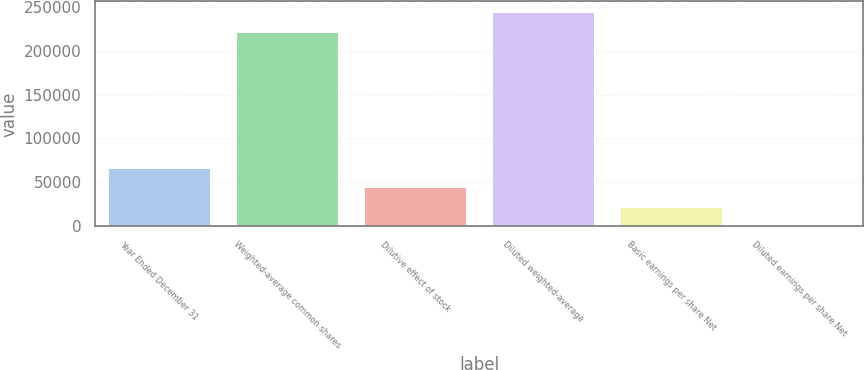Convert chart to OTSL. <chart><loc_0><loc_0><loc_500><loc_500><bar_chart><fcel>Year Ended December 31<fcel>Weighted-average common shares<fcel>Dilutive effect of stock<fcel>Diluted weighted-average<fcel>Basic earnings per share Net<fcel>Diluted earnings per share Net<nl><fcel>66915.6<fcel>221658<fcel>44611.6<fcel>243962<fcel>22307.5<fcel>3.43<nl></chart> 